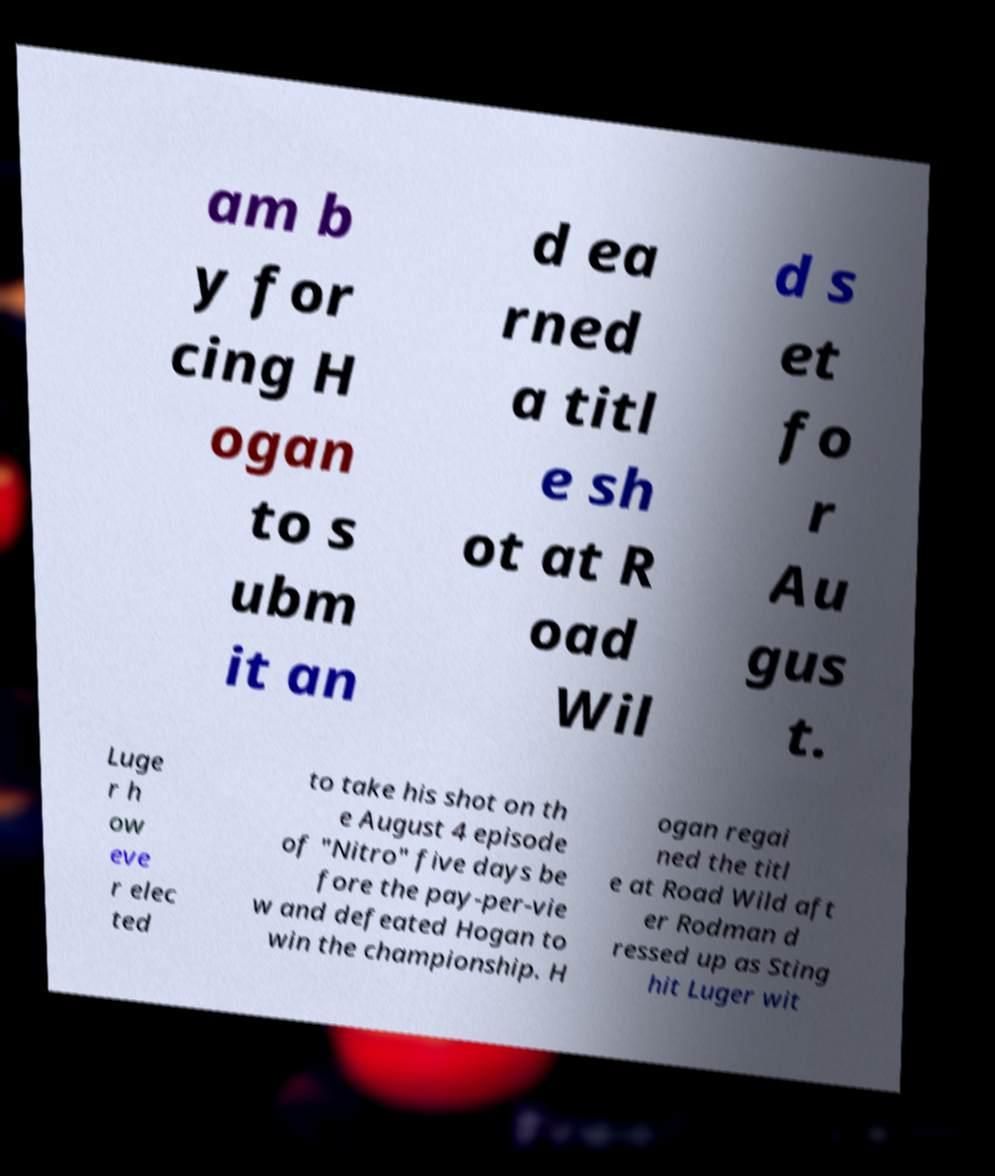What messages or text are displayed in this image? I need them in a readable, typed format. am b y for cing H ogan to s ubm it an d ea rned a titl e sh ot at R oad Wil d s et fo r Au gus t. Luge r h ow eve r elec ted to take his shot on th e August 4 episode of "Nitro" five days be fore the pay-per-vie w and defeated Hogan to win the championship. H ogan regai ned the titl e at Road Wild aft er Rodman d ressed up as Sting hit Luger wit 